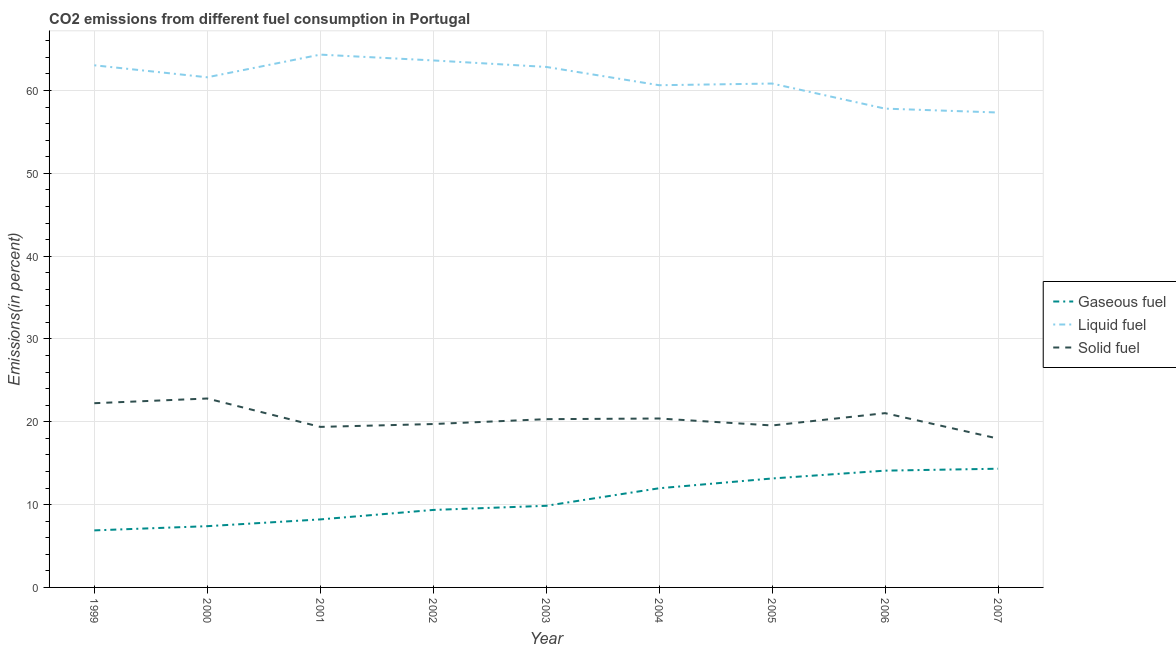What is the percentage of liquid fuel emission in 2003?
Keep it short and to the point. 62.85. Across all years, what is the maximum percentage of solid fuel emission?
Ensure brevity in your answer.  22.81. Across all years, what is the minimum percentage of liquid fuel emission?
Provide a succinct answer. 57.34. In which year was the percentage of gaseous fuel emission minimum?
Offer a terse response. 1999. What is the total percentage of liquid fuel emission in the graph?
Your answer should be compact. 552.1. What is the difference between the percentage of gaseous fuel emission in 2001 and that in 2003?
Provide a succinct answer. -1.64. What is the difference between the percentage of solid fuel emission in 2007 and the percentage of gaseous fuel emission in 2006?
Ensure brevity in your answer.  3.87. What is the average percentage of solid fuel emission per year?
Offer a very short reply. 20.38. In the year 2004, what is the difference between the percentage of gaseous fuel emission and percentage of liquid fuel emission?
Make the answer very short. -48.66. What is the ratio of the percentage of gaseous fuel emission in 2003 to that in 2006?
Provide a short and direct response. 0.7. What is the difference between the highest and the second highest percentage of gaseous fuel emission?
Offer a terse response. 0.23. What is the difference between the highest and the lowest percentage of gaseous fuel emission?
Your answer should be very brief. 7.45. Is it the case that in every year, the sum of the percentage of gaseous fuel emission and percentage of liquid fuel emission is greater than the percentage of solid fuel emission?
Keep it short and to the point. Yes. Are the values on the major ticks of Y-axis written in scientific E-notation?
Your answer should be compact. No. Does the graph contain any zero values?
Offer a very short reply. No. Where does the legend appear in the graph?
Provide a short and direct response. Center right. How are the legend labels stacked?
Your answer should be compact. Vertical. What is the title of the graph?
Your answer should be compact. CO2 emissions from different fuel consumption in Portugal. What is the label or title of the Y-axis?
Ensure brevity in your answer.  Emissions(in percent). What is the Emissions(in percent) in Gaseous fuel in 1999?
Provide a short and direct response. 6.89. What is the Emissions(in percent) of Liquid fuel in 1999?
Your answer should be compact. 63.05. What is the Emissions(in percent) of Solid fuel in 1999?
Your response must be concise. 22.24. What is the Emissions(in percent) in Gaseous fuel in 2000?
Ensure brevity in your answer.  7.4. What is the Emissions(in percent) in Liquid fuel in 2000?
Ensure brevity in your answer.  61.6. What is the Emissions(in percent) of Solid fuel in 2000?
Your answer should be very brief. 22.81. What is the Emissions(in percent) in Gaseous fuel in 2001?
Make the answer very short. 8.21. What is the Emissions(in percent) in Liquid fuel in 2001?
Provide a succinct answer. 64.34. What is the Emissions(in percent) of Solid fuel in 2001?
Your answer should be very brief. 19.38. What is the Emissions(in percent) of Gaseous fuel in 2002?
Keep it short and to the point. 9.36. What is the Emissions(in percent) of Liquid fuel in 2002?
Your response must be concise. 63.63. What is the Emissions(in percent) in Solid fuel in 2002?
Provide a short and direct response. 19.73. What is the Emissions(in percent) of Gaseous fuel in 2003?
Offer a very short reply. 9.86. What is the Emissions(in percent) in Liquid fuel in 2003?
Provide a succinct answer. 62.85. What is the Emissions(in percent) in Solid fuel in 2003?
Your response must be concise. 20.32. What is the Emissions(in percent) in Gaseous fuel in 2004?
Your answer should be compact. 11.97. What is the Emissions(in percent) of Liquid fuel in 2004?
Provide a succinct answer. 60.64. What is the Emissions(in percent) in Solid fuel in 2004?
Offer a very short reply. 20.4. What is the Emissions(in percent) in Gaseous fuel in 2005?
Your answer should be very brief. 13.16. What is the Emissions(in percent) in Liquid fuel in 2005?
Your answer should be compact. 60.84. What is the Emissions(in percent) of Solid fuel in 2005?
Offer a terse response. 19.56. What is the Emissions(in percent) of Gaseous fuel in 2006?
Provide a short and direct response. 14.1. What is the Emissions(in percent) in Liquid fuel in 2006?
Provide a succinct answer. 57.81. What is the Emissions(in percent) in Solid fuel in 2006?
Provide a short and direct response. 21.04. What is the Emissions(in percent) of Gaseous fuel in 2007?
Give a very brief answer. 14.33. What is the Emissions(in percent) of Liquid fuel in 2007?
Provide a short and direct response. 57.34. What is the Emissions(in percent) in Solid fuel in 2007?
Offer a terse response. 17.97. Across all years, what is the maximum Emissions(in percent) of Gaseous fuel?
Your answer should be very brief. 14.33. Across all years, what is the maximum Emissions(in percent) of Liquid fuel?
Keep it short and to the point. 64.34. Across all years, what is the maximum Emissions(in percent) of Solid fuel?
Ensure brevity in your answer.  22.81. Across all years, what is the minimum Emissions(in percent) of Gaseous fuel?
Make the answer very short. 6.89. Across all years, what is the minimum Emissions(in percent) in Liquid fuel?
Provide a short and direct response. 57.34. Across all years, what is the minimum Emissions(in percent) in Solid fuel?
Make the answer very short. 17.97. What is the total Emissions(in percent) of Gaseous fuel in the graph?
Ensure brevity in your answer.  95.27. What is the total Emissions(in percent) of Liquid fuel in the graph?
Your answer should be compact. 552.1. What is the total Emissions(in percent) in Solid fuel in the graph?
Your answer should be compact. 183.45. What is the difference between the Emissions(in percent) of Gaseous fuel in 1999 and that in 2000?
Offer a terse response. -0.51. What is the difference between the Emissions(in percent) in Liquid fuel in 1999 and that in 2000?
Your response must be concise. 1.45. What is the difference between the Emissions(in percent) of Solid fuel in 1999 and that in 2000?
Ensure brevity in your answer.  -0.57. What is the difference between the Emissions(in percent) of Gaseous fuel in 1999 and that in 2001?
Your answer should be very brief. -1.33. What is the difference between the Emissions(in percent) in Liquid fuel in 1999 and that in 2001?
Your response must be concise. -1.29. What is the difference between the Emissions(in percent) of Solid fuel in 1999 and that in 2001?
Give a very brief answer. 2.86. What is the difference between the Emissions(in percent) in Gaseous fuel in 1999 and that in 2002?
Offer a very short reply. -2.47. What is the difference between the Emissions(in percent) in Liquid fuel in 1999 and that in 2002?
Make the answer very short. -0.59. What is the difference between the Emissions(in percent) of Solid fuel in 1999 and that in 2002?
Give a very brief answer. 2.51. What is the difference between the Emissions(in percent) of Gaseous fuel in 1999 and that in 2003?
Provide a short and direct response. -2.97. What is the difference between the Emissions(in percent) in Liquid fuel in 1999 and that in 2003?
Your answer should be very brief. 0.2. What is the difference between the Emissions(in percent) in Solid fuel in 1999 and that in 2003?
Your answer should be very brief. 1.93. What is the difference between the Emissions(in percent) in Gaseous fuel in 1999 and that in 2004?
Offer a terse response. -5.09. What is the difference between the Emissions(in percent) of Liquid fuel in 1999 and that in 2004?
Offer a terse response. 2.41. What is the difference between the Emissions(in percent) in Solid fuel in 1999 and that in 2004?
Your response must be concise. 1.85. What is the difference between the Emissions(in percent) in Gaseous fuel in 1999 and that in 2005?
Provide a short and direct response. -6.27. What is the difference between the Emissions(in percent) of Liquid fuel in 1999 and that in 2005?
Provide a succinct answer. 2.2. What is the difference between the Emissions(in percent) of Solid fuel in 1999 and that in 2005?
Offer a terse response. 2.69. What is the difference between the Emissions(in percent) in Gaseous fuel in 1999 and that in 2006?
Make the answer very short. -7.21. What is the difference between the Emissions(in percent) in Liquid fuel in 1999 and that in 2006?
Ensure brevity in your answer.  5.23. What is the difference between the Emissions(in percent) in Solid fuel in 1999 and that in 2006?
Offer a terse response. 1.2. What is the difference between the Emissions(in percent) of Gaseous fuel in 1999 and that in 2007?
Offer a terse response. -7.45. What is the difference between the Emissions(in percent) in Liquid fuel in 1999 and that in 2007?
Your response must be concise. 5.7. What is the difference between the Emissions(in percent) in Solid fuel in 1999 and that in 2007?
Offer a terse response. 4.27. What is the difference between the Emissions(in percent) of Gaseous fuel in 2000 and that in 2001?
Make the answer very short. -0.82. What is the difference between the Emissions(in percent) of Liquid fuel in 2000 and that in 2001?
Offer a terse response. -2.74. What is the difference between the Emissions(in percent) in Solid fuel in 2000 and that in 2001?
Your answer should be very brief. 3.43. What is the difference between the Emissions(in percent) of Gaseous fuel in 2000 and that in 2002?
Keep it short and to the point. -1.96. What is the difference between the Emissions(in percent) of Liquid fuel in 2000 and that in 2002?
Give a very brief answer. -2.03. What is the difference between the Emissions(in percent) of Solid fuel in 2000 and that in 2002?
Your answer should be compact. 3.08. What is the difference between the Emissions(in percent) of Gaseous fuel in 2000 and that in 2003?
Keep it short and to the point. -2.46. What is the difference between the Emissions(in percent) of Liquid fuel in 2000 and that in 2003?
Your answer should be very brief. -1.25. What is the difference between the Emissions(in percent) in Solid fuel in 2000 and that in 2003?
Your answer should be very brief. 2.49. What is the difference between the Emissions(in percent) in Gaseous fuel in 2000 and that in 2004?
Provide a succinct answer. -4.58. What is the difference between the Emissions(in percent) in Liquid fuel in 2000 and that in 2004?
Give a very brief answer. 0.96. What is the difference between the Emissions(in percent) in Solid fuel in 2000 and that in 2004?
Offer a very short reply. 2.41. What is the difference between the Emissions(in percent) in Gaseous fuel in 2000 and that in 2005?
Make the answer very short. -5.76. What is the difference between the Emissions(in percent) of Liquid fuel in 2000 and that in 2005?
Keep it short and to the point. 0.76. What is the difference between the Emissions(in percent) of Solid fuel in 2000 and that in 2005?
Provide a short and direct response. 3.26. What is the difference between the Emissions(in percent) in Gaseous fuel in 2000 and that in 2006?
Offer a terse response. -6.71. What is the difference between the Emissions(in percent) of Liquid fuel in 2000 and that in 2006?
Your answer should be very brief. 3.78. What is the difference between the Emissions(in percent) of Solid fuel in 2000 and that in 2006?
Provide a short and direct response. 1.77. What is the difference between the Emissions(in percent) in Gaseous fuel in 2000 and that in 2007?
Provide a short and direct response. -6.94. What is the difference between the Emissions(in percent) in Liquid fuel in 2000 and that in 2007?
Ensure brevity in your answer.  4.25. What is the difference between the Emissions(in percent) in Solid fuel in 2000 and that in 2007?
Ensure brevity in your answer.  4.84. What is the difference between the Emissions(in percent) in Gaseous fuel in 2001 and that in 2002?
Make the answer very short. -1.14. What is the difference between the Emissions(in percent) of Liquid fuel in 2001 and that in 2002?
Your answer should be compact. 0.7. What is the difference between the Emissions(in percent) in Solid fuel in 2001 and that in 2002?
Make the answer very short. -0.34. What is the difference between the Emissions(in percent) of Gaseous fuel in 2001 and that in 2003?
Your answer should be compact. -1.64. What is the difference between the Emissions(in percent) in Liquid fuel in 2001 and that in 2003?
Provide a succinct answer. 1.49. What is the difference between the Emissions(in percent) in Solid fuel in 2001 and that in 2003?
Provide a succinct answer. -0.93. What is the difference between the Emissions(in percent) in Gaseous fuel in 2001 and that in 2004?
Offer a very short reply. -3.76. What is the difference between the Emissions(in percent) of Liquid fuel in 2001 and that in 2004?
Your answer should be compact. 3.7. What is the difference between the Emissions(in percent) in Solid fuel in 2001 and that in 2004?
Ensure brevity in your answer.  -1.01. What is the difference between the Emissions(in percent) of Gaseous fuel in 2001 and that in 2005?
Keep it short and to the point. -4.94. What is the difference between the Emissions(in percent) of Liquid fuel in 2001 and that in 2005?
Offer a very short reply. 3.49. What is the difference between the Emissions(in percent) of Solid fuel in 2001 and that in 2005?
Ensure brevity in your answer.  -0.17. What is the difference between the Emissions(in percent) in Gaseous fuel in 2001 and that in 2006?
Offer a terse response. -5.89. What is the difference between the Emissions(in percent) in Liquid fuel in 2001 and that in 2006?
Provide a succinct answer. 6.52. What is the difference between the Emissions(in percent) in Solid fuel in 2001 and that in 2006?
Make the answer very short. -1.66. What is the difference between the Emissions(in percent) in Gaseous fuel in 2001 and that in 2007?
Make the answer very short. -6.12. What is the difference between the Emissions(in percent) in Liquid fuel in 2001 and that in 2007?
Your response must be concise. 6.99. What is the difference between the Emissions(in percent) of Solid fuel in 2001 and that in 2007?
Your response must be concise. 1.41. What is the difference between the Emissions(in percent) of Gaseous fuel in 2002 and that in 2003?
Ensure brevity in your answer.  -0.5. What is the difference between the Emissions(in percent) in Liquid fuel in 2002 and that in 2003?
Your response must be concise. 0.78. What is the difference between the Emissions(in percent) of Solid fuel in 2002 and that in 2003?
Provide a short and direct response. -0.59. What is the difference between the Emissions(in percent) in Gaseous fuel in 2002 and that in 2004?
Ensure brevity in your answer.  -2.62. What is the difference between the Emissions(in percent) in Liquid fuel in 2002 and that in 2004?
Give a very brief answer. 2.99. What is the difference between the Emissions(in percent) in Solid fuel in 2002 and that in 2004?
Provide a short and direct response. -0.67. What is the difference between the Emissions(in percent) in Gaseous fuel in 2002 and that in 2005?
Your answer should be very brief. -3.8. What is the difference between the Emissions(in percent) in Liquid fuel in 2002 and that in 2005?
Your answer should be compact. 2.79. What is the difference between the Emissions(in percent) of Solid fuel in 2002 and that in 2005?
Provide a succinct answer. 0.17. What is the difference between the Emissions(in percent) in Gaseous fuel in 2002 and that in 2006?
Make the answer very short. -4.74. What is the difference between the Emissions(in percent) of Liquid fuel in 2002 and that in 2006?
Offer a very short reply. 5.82. What is the difference between the Emissions(in percent) of Solid fuel in 2002 and that in 2006?
Ensure brevity in your answer.  -1.31. What is the difference between the Emissions(in percent) in Gaseous fuel in 2002 and that in 2007?
Provide a short and direct response. -4.98. What is the difference between the Emissions(in percent) in Liquid fuel in 2002 and that in 2007?
Provide a succinct answer. 6.29. What is the difference between the Emissions(in percent) in Solid fuel in 2002 and that in 2007?
Your response must be concise. 1.76. What is the difference between the Emissions(in percent) in Gaseous fuel in 2003 and that in 2004?
Give a very brief answer. -2.12. What is the difference between the Emissions(in percent) of Liquid fuel in 2003 and that in 2004?
Your answer should be compact. 2.21. What is the difference between the Emissions(in percent) of Solid fuel in 2003 and that in 2004?
Keep it short and to the point. -0.08. What is the difference between the Emissions(in percent) in Gaseous fuel in 2003 and that in 2005?
Offer a very short reply. -3.3. What is the difference between the Emissions(in percent) of Liquid fuel in 2003 and that in 2005?
Your response must be concise. 2.01. What is the difference between the Emissions(in percent) of Solid fuel in 2003 and that in 2005?
Offer a very short reply. 0.76. What is the difference between the Emissions(in percent) in Gaseous fuel in 2003 and that in 2006?
Keep it short and to the point. -4.25. What is the difference between the Emissions(in percent) in Liquid fuel in 2003 and that in 2006?
Make the answer very short. 5.03. What is the difference between the Emissions(in percent) of Solid fuel in 2003 and that in 2006?
Offer a terse response. -0.73. What is the difference between the Emissions(in percent) of Gaseous fuel in 2003 and that in 2007?
Make the answer very short. -4.48. What is the difference between the Emissions(in percent) of Liquid fuel in 2003 and that in 2007?
Offer a very short reply. 5.5. What is the difference between the Emissions(in percent) in Solid fuel in 2003 and that in 2007?
Provide a short and direct response. 2.35. What is the difference between the Emissions(in percent) in Gaseous fuel in 2004 and that in 2005?
Provide a short and direct response. -1.18. What is the difference between the Emissions(in percent) in Liquid fuel in 2004 and that in 2005?
Make the answer very short. -0.2. What is the difference between the Emissions(in percent) of Solid fuel in 2004 and that in 2005?
Provide a succinct answer. 0.84. What is the difference between the Emissions(in percent) of Gaseous fuel in 2004 and that in 2006?
Ensure brevity in your answer.  -2.13. What is the difference between the Emissions(in percent) of Liquid fuel in 2004 and that in 2006?
Provide a short and direct response. 2.83. What is the difference between the Emissions(in percent) of Solid fuel in 2004 and that in 2006?
Your answer should be compact. -0.65. What is the difference between the Emissions(in percent) of Gaseous fuel in 2004 and that in 2007?
Ensure brevity in your answer.  -2.36. What is the difference between the Emissions(in percent) in Liquid fuel in 2004 and that in 2007?
Keep it short and to the point. 3.3. What is the difference between the Emissions(in percent) of Solid fuel in 2004 and that in 2007?
Provide a short and direct response. 2.42. What is the difference between the Emissions(in percent) in Gaseous fuel in 2005 and that in 2006?
Provide a succinct answer. -0.95. What is the difference between the Emissions(in percent) of Liquid fuel in 2005 and that in 2006?
Your response must be concise. 3.03. What is the difference between the Emissions(in percent) in Solid fuel in 2005 and that in 2006?
Offer a terse response. -1.49. What is the difference between the Emissions(in percent) of Gaseous fuel in 2005 and that in 2007?
Provide a succinct answer. -1.18. What is the difference between the Emissions(in percent) of Liquid fuel in 2005 and that in 2007?
Offer a terse response. 3.5. What is the difference between the Emissions(in percent) of Solid fuel in 2005 and that in 2007?
Your response must be concise. 1.58. What is the difference between the Emissions(in percent) in Gaseous fuel in 2006 and that in 2007?
Make the answer very short. -0.23. What is the difference between the Emissions(in percent) of Liquid fuel in 2006 and that in 2007?
Give a very brief answer. 0.47. What is the difference between the Emissions(in percent) of Solid fuel in 2006 and that in 2007?
Your answer should be compact. 3.07. What is the difference between the Emissions(in percent) of Gaseous fuel in 1999 and the Emissions(in percent) of Liquid fuel in 2000?
Keep it short and to the point. -54.71. What is the difference between the Emissions(in percent) in Gaseous fuel in 1999 and the Emissions(in percent) in Solid fuel in 2000?
Ensure brevity in your answer.  -15.92. What is the difference between the Emissions(in percent) of Liquid fuel in 1999 and the Emissions(in percent) of Solid fuel in 2000?
Your answer should be very brief. 40.23. What is the difference between the Emissions(in percent) in Gaseous fuel in 1999 and the Emissions(in percent) in Liquid fuel in 2001?
Give a very brief answer. -57.45. What is the difference between the Emissions(in percent) of Gaseous fuel in 1999 and the Emissions(in percent) of Solid fuel in 2001?
Keep it short and to the point. -12.5. What is the difference between the Emissions(in percent) in Liquid fuel in 1999 and the Emissions(in percent) in Solid fuel in 2001?
Offer a very short reply. 43.66. What is the difference between the Emissions(in percent) in Gaseous fuel in 1999 and the Emissions(in percent) in Liquid fuel in 2002?
Provide a succinct answer. -56.74. What is the difference between the Emissions(in percent) of Gaseous fuel in 1999 and the Emissions(in percent) of Solid fuel in 2002?
Your answer should be compact. -12.84. What is the difference between the Emissions(in percent) of Liquid fuel in 1999 and the Emissions(in percent) of Solid fuel in 2002?
Provide a short and direct response. 43.32. What is the difference between the Emissions(in percent) in Gaseous fuel in 1999 and the Emissions(in percent) in Liquid fuel in 2003?
Keep it short and to the point. -55.96. What is the difference between the Emissions(in percent) in Gaseous fuel in 1999 and the Emissions(in percent) in Solid fuel in 2003?
Provide a short and direct response. -13.43. What is the difference between the Emissions(in percent) of Liquid fuel in 1999 and the Emissions(in percent) of Solid fuel in 2003?
Offer a very short reply. 42.73. What is the difference between the Emissions(in percent) in Gaseous fuel in 1999 and the Emissions(in percent) in Liquid fuel in 2004?
Give a very brief answer. -53.75. What is the difference between the Emissions(in percent) of Gaseous fuel in 1999 and the Emissions(in percent) of Solid fuel in 2004?
Keep it short and to the point. -13.51. What is the difference between the Emissions(in percent) in Liquid fuel in 1999 and the Emissions(in percent) in Solid fuel in 2004?
Keep it short and to the point. 42.65. What is the difference between the Emissions(in percent) in Gaseous fuel in 1999 and the Emissions(in percent) in Liquid fuel in 2005?
Provide a succinct answer. -53.95. What is the difference between the Emissions(in percent) of Gaseous fuel in 1999 and the Emissions(in percent) of Solid fuel in 2005?
Ensure brevity in your answer.  -12.67. What is the difference between the Emissions(in percent) of Liquid fuel in 1999 and the Emissions(in percent) of Solid fuel in 2005?
Your response must be concise. 43.49. What is the difference between the Emissions(in percent) in Gaseous fuel in 1999 and the Emissions(in percent) in Liquid fuel in 2006?
Provide a short and direct response. -50.93. What is the difference between the Emissions(in percent) in Gaseous fuel in 1999 and the Emissions(in percent) in Solid fuel in 2006?
Offer a very short reply. -14.16. What is the difference between the Emissions(in percent) of Liquid fuel in 1999 and the Emissions(in percent) of Solid fuel in 2006?
Provide a succinct answer. 42. What is the difference between the Emissions(in percent) in Gaseous fuel in 1999 and the Emissions(in percent) in Liquid fuel in 2007?
Provide a short and direct response. -50.46. What is the difference between the Emissions(in percent) in Gaseous fuel in 1999 and the Emissions(in percent) in Solid fuel in 2007?
Your answer should be compact. -11.08. What is the difference between the Emissions(in percent) in Liquid fuel in 1999 and the Emissions(in percent) in Solid fuel in 2007?
Ensure brevity in your answer.  45.07. What is the difference between the Emissions(in percent) of Gaseous fuel in 2000 and the Emissions(in percent) of Liquid fuel in 2001?
Provide a succinct answer. -56.94. What is the difference between the Emissions(in percent) of Gaseous fuel in 2000 and the Emissions(in percent) of Solid fuel in 2001?
Ensure brevity in your answer.  -11.99. What is the difference between the Emissions(in percent) of Liquid fuel in 2000 and the Emissions(in percent) of Solid fuel in 2001?
Ensure brevity in your answer.  42.21. What is the difference between the Emissions(in percent) in Gaseous fuel in 2000 and the Emissions(in percent) in Liquid fuel in 2002?
Your answer should be very brief. -56.24. What is the difference between the Emissions(in percent) of Gaseous fuel in 2000 and the Emissions(in percent) of Solid fuel in 2002?
Offer a terse response. -12.33. What is the difference between the Emissions(in percent) in Liquid fuel in 2000 and the Emissions(in percent) in Solid fuel in 2002?
Keep it short and to the point. 41.87. What is the difference between the Emissions(in percent) in Gaseous fuel in 2000 and the Emissions(in percent) in Liquid fuel in 2003?
Keep it short and to the point. -55.45. What is the difference between the Emissions(in percent) of Gaseous fuel in 2000 and the Emissions(in percent) of Solid fuel in 2003?
Your answer should be compact. -12.92. What is the difference between the Emissions(in percent) of Liquid fuel in 2000 and the Emissions(in percent) of Solid fuel in 2003?
Keep it short and to the point. 41.28. What is the difference between the Emissions(in percent) of Gaseous fuel in 2000 and the Emissions(in percent) of Liquid fuel in 2004?
Keep it short and to the point. -53.24. What is the difference between the Emissions(in percent) in Gaseous fuel in 2000 and the Emissions(in percent) in Solid fuel in 2004?
Keep it short and to the point. -13. What is the difference between the Emissions(in percent) of Liquid fuel in 2000 and the Emissions(in percent) of Solid fuel in 2004?
Your response must be concise. 41.2. What is the difference between the Emissions(in percent) of Gaseous fuel in 2000 and the Emissions(in percent) of Liquid fuel in 2005?
Offer a terse response. -53.45. What is the difference between the Emissions(in percent) of Gaseous fuel in 2000 and the Emissions(in percent) of Solid fuel in 2005?
Give a very brief answer. -12.16. What is the difference between the Emissions(in percent) in Liquid fuel in 2000 and the Emissions(in percent) in Solid fuel in 2005?
Your response must be concise. 42.04. What is the difference between the Emissions(in percent) in Gaseous fuel in 2000 and the Emissions(in percent) in Liquid fuel in 2006?
Ensure brevity in your answer.  -50.42. What is the difference between the Emissions(in percent) in Gaseous fuel in 2000 and the Emissions(in percent) in Solid fuel in 2006?
Offer a very short reply. -13.65. What is the difference between the Emissions(in percent) in Liquid fuel in 2000 and the Emissions(in percent) in Solid fuel in 2006?
Offer a very short reply. 40.55. What is the difference between the Emissions(in percent) in Gaseous fuel in 2000 and the Emissions(in percent) in Liquid fuel in 2007?
Provide a succinct answer. -49.95. What is the difference between the Emissions(in percent) of Gaseous fuel in 2000 and the Emissions(in percent) of Solid fuel in 2007?
Make the answer very short. -10.58. What is the difference between the Emissions(in percent) of Liquid fuel in 2000 and the Emissions(in percent) of Solid fuel in 2007?
Make the answer very short. 43.63. What is the difference between the Emissions(in percent) of Gaseous fuel in 2001 and the Emissions(in percent) of Liquid fuel in 2002?
Your answer should be compact. -55.42. What is the difference between the Emissions(in percent) of Gaseous fuel in 2001 and the Emissions(in percent) of Solid fuel in 2002?
Offer a very short reply. -11.52. What is the difference between the Emissions(in percent) of Liquid fuel in 2001 and the Emissions(in percent) of Solid fuel in 2002?
Your answer should be compact. 44.61. What is the difference between the Emissions(in percent) in Gaseous fuel in 2001 and the Emissions(in percent) in Liquid fuel in 2003?
Your answer should be compact. -54.64. What is the difference between the Emissions(in percent) in Gaseous fuel in 2001 and the Emissions(in percent) in Solid fuel in 2003?
Make the answer very short. -12.1. What is the difference between the Emissions(in percent) in Liquid fuel in 2001 and the Emissions(in percent) in Solid fuel in 2003?
Your response must be concise. 44.02. What is the difference between the Emissions(in percent) of Gaseous fuel in 2001 and the Emissions(in percent) of Liquid fuel in 2004?
Your answer should be compact. -52.43. What is the difference between the Emissions(in percent) in Gaseous fuel in 2001 and the Emissions(in percent) in Solid fuel in 2004?
Your answer should be compact. -12.18. What is the difference between the Emissions(in percent) in Liquid fuel in 2001 and the Emissions(in percent) in Solid fuel in 2004?
Your answer should be very brief. 43.94. What is the difference between the Emissions(in percent) of Gaseous fuel in 2001 and the Emissions(in percent) of Liquid fuel in 2005?
Offer a very short reply. -52.63. What is the difference between the Emissions(in percent) in Gaseous fuel in 2001 and the Emissions(in percent) in Solid fuel in 2005?
Make the answer very short. -11.34. What is the difference between the Emissions(in percent) of Liquid fuel in 2001 and the Emissions(in percent) of Solid fuel in 2005?
Your answer should be very brief. 44.78. What is the difference between the Emissions(in percent) of Gaseous fuel in 2001 and the Emissions(in percent) of Liquid fuel in 2006?
Provide a short and direct response. -49.6. What is the difference between the Emissions(in percent) of Gaseous fuel in 2001 and the Emissions(in percent) of Solid fuel in 2006?
Make the answer very short. -12.83. What is the difference between the Emissions(in percent) of Liquid fuel in 2001 and the Emissions(in percent) of Solid fuel in 2006?
Offer a very short reply. 43.29. What is the difference between the Emissions(in percent) of Gaseous fuel in 2001 and the Emissions(in percent) of Liquid fuel in 2007?
Your answer should be compact. -49.13. What is the difference between the Emissions(in percent) in Gaseous fuel in 2001 and the Emissions(in percent) in Solid fuel in 2007?
Your answer should be very brief. -9.76. What is the difference between the Emissions(in percent) of Liquid fuel in 2001 and the Emissions(in percent) of Solid fuel in 2007?
Ensure brevity in your answer.  46.36. What is the difference between the Emissions(in percent) of Gaseous fuel in 2002 and the Emissions(in percent) of Liquid fuel in 2003?
Your answer should be very brief. -53.49. What is the difference between the Emissions(in percent) of Gaseous fuel in 2002 and the Emissions(in percent) of Solid fuel in 2003?
Your response must be concise. -10.96. What is the difference between the Emissions(in percent) in Liquid fuel in 2002 and the Emissions(in percent) in Solid fuel in 2003?
Your answer should be very brief. 43.31. What is the difference between the Emissions(in percent) in Gaseous fuel in 2002 and the Emissions(in percent) in Liquid fuel in 2004?
Provide a succinct answer. -51.28. What is the difference between the Emissions(in percent) in Gaseous fuel in 2002 and the Emissions(in percent) in Solid fuel in 2004?
Provide a short and direct response. -11.04. What is the difference between the Emissions(in percent) of Liquid fuel in 2002 and the Emissions(in percent) of Solid fuel in 2004?
Ensure brevity in your answer.  43.23. What is the difference between the Emissions(in percent) of Gaseous fuel in 2002 and the Emissions(in percent) of Liquid fuel in 2005?
Provide a short and direct response. -51.49. What is the difference between the Emissions(in percent) of Gaseous fuel in 2002 and the Emissions(in percent) of Solid fuel in 2005?
Your answer should be compact. -10.2. What is the difference between the Emissions(in percent) in Liquid fuel in 2002 and the Emissions(in percent) in Solid fuel in 2005?
Ensure brevity in your answer.  44.08. What is the difference between the Emissions(in percent) of Gaseous fuel in 2002 and the Emissions(in percent) of Liquid fuel in 2006?
Give a very brief answer. -48.46. What is the difference between the Emissions(in percent) in Gaseous fuel in 2002 and the Emissions(in percent) in Solid fuel in 2006?
Your response must be concise. -11.69. What is the difference between the Emissions(in percent) of Liquid fuel in 2002 and the Emissions(in percent) of Solid fuel in 2006?
Ensure brevity in your answer.  42.59. What is the difference between the Emissions(in percent) in Gaseous fuel in 2002 and the Emissions(in percent) in Liquid fuel in 2007?
Offer a terse response. -47.99. What is the difference between the Emissions(in percent) of Gaseous fuel in 2002 and the Emissions(in percent) of Solid fuel in 2007?
Keep it short and to the point. -8.62. What is the difference between the Emissions(in percent) in Liquid fuel in 2002 and the Emissions(in percent) in Solid fuel in 2007?
Provide a short and direct response. 45.66. What is the difference between the Emissions(in percent) in Gaseous fuel in 2003 and the Emissions(in percent) in Liquid fuel in 2004?
Provide a succinct answer. -50.78. What is the difference between the Emissions(in percent) in Gaseous fuel in 2003 and the Emissions(in percent) in Solid fuel in 2004?
Provide a short and direct response. -10.54. What is the difference between the Emissions(in percent) in Liquid fuel in 2003 and the Emissions(in percent) in Solid fuel in 2004?
Offer a very short reply. 42.45. What is the difference between the Emissions(in percent) in Gaseous fuel in 2003 and the Emissions(in percent) in Liquid fuel in 2005?
Offer a very short reply. -50.99. What is the difference between the Emissions(in percent) of Gaseous fuel in 2003 and the Emissions(in percent) of Solid fuel in 2005?
Keep it short and to the point. -9.7. What is the difference between the Emissions(in percent) in Liquid fuel in 2003 and the Emissions(in percent) in Solid fuel in 2005?
Ensure brevity in your answer.  43.29. What is the difference between the Emissions(in percent) in Gaseous fuel in 2003 and the Emissions(in percent) in Liquid fuel in 2006?
Keep it short and to the point. -47.96. What is the difference between the Emissions(in percent) of Gaseous fuel in 2003 and the Emissions(in percent) of Solid fuel in 2006?
Your answer should be compact. -11.19. What is the difference between the Emissions(in percent) of Liquid fuel in 2003 and the Emissions(in percent) of Solid fuel in 2006?
Your answer should be compact. 41.81. What is the difference between the Emissions(in percent) of Gaseous fuel in 2003 and the Emissions(in percent) of Liquid fuel in 2007?
Make the answer very short. -47.49. What is the difference between the Emissions(in percent) of Gaseous fuel in 2003 and the Emissions(in percent) of Solid fuel in 2007?
Your response must be concise. -8.12. What is the difference between the Emissions(in percent) of Liquid fuel in 2003 and the Emissions(in percent) of Solid fuel in 2007?
Your answer should be very brief. 44.88. What is the difference between the Emissions(in percent) in Gaseous fuel in 2004 and the Emissions(in percent) in Liquid fuel in 2005?
Your answer should be very brief. -48.87. What is the difference between the Emissions(in percent) in Gaseous fuel in 2004 and the Emissions(in percent) in Solid fuel in 2005?
Keep it short and to the point. -7.58. What is the difference between the Emissions(in percent) in Liquid fuel in 2004 and the Emissions(in percent) in Solid fuel in 2005?
Offer a very short reply. 41.08. What is the difference between the Emissions(in percent) of Gaseous fuel in 2004 and the Emissions(in percent) of Liquid fuel in 2006?
Keep it short and to the point. -45.84. What is the difference between the Emissions(in percent) in Gaseous fuel in 2004 and the Emissions(in percent) in Solid fuel in 2006?
Offer a very short reply. -9.07. What is the difference between the Emissions(in percent) of Liquid fuel in 2004 and the Emissions(in percent) of Solid fuel in 2006?
Keep it short and to the point. 39.6. What is the difference between the Emissions(in percent) in Gaseous fuel in 2004 and the Emissions(in percent) in Liquid fuel in 2007?
Offer a very short reply. -45.37. What is the difference between the Emissions(in percent) in Gaseous fuel in 2004 and the Emissions(in percent) in Solid fuel in 2007?
Offer a terse response. -6. What is the difference between the Emissions(in percent) of Liquid fuel in 2004 and the Emissions(in percent) of Solid fuel in 2007?
Your answer should be very brief. 42.67. What is the difference between the Emissions(in percent) in Gaseous fuel in 2005 and the Emissions(in percent) in Liquid fuel in 2006?
Your response must be concise. -44.66. What is the difference between the Emissions(in percent) of Gaseous fuel in 2005 and the Emissions(in percent) of Solid fuel in 2006?
Make the answer very short. -7.89. What is the difference between the Emissions(in percent) in Liquid fuel in 2005 and the Emissions(in percent) in Solid fuel in 2006?
Your response must be concise. 39.8. What is the difference between the Emissions(in percent) of Gaseous fuel in 2005 and the Emissions(in percent) of Liquid fuel in 2007?
Ensure brevity in your answer.  -44.19. What is the difference between the Emissions(in percent) in Gaseous fuel in 2005 and the Emissions(in percent) in Solid fuel in 2007?
Ensure brevity in your answer.  -4.82. What is the difference between the Emissions(in percent) in Liquid fuel in 2005 and the Emissions(in percent) in Solid fuel in 2007?
Provide a short and direct response. 42.87. What is the difference between the Emissions(in percent) in Gaseous fuel in 2006 and the Emissions(in percent) in Liquid fuel in 2007?
Offer a terse response. -43.24. What is the difference between the Emissions(in percent) of Gaseous fuel in 2006 and the Emissions(in percent) of Solid fuel in 2007?
Your answer should be very brief. -3.87. What is the difference between the Emissions(in percent) in Liquid fuel in 2006 and the Emissions(in percent) in Solid fuel in 2007?
Offer a very short reply. 39.84. What is the average Emissions(in percent) in Gaseous fuel per year?
Make the answer very short. 10.59. What is the average Emissions(in percent) in Liquid fuel per year?
Make the answer very short. 61.34. What is the average Emissions(in percent) in Solid fuel per year?
Your answer should be very brief. 20.38. In the year 1999, what is the difference between the Emissions(in percent) in Gaseous fuel and Emissions(in percent) in Liquid fuel?
Keep it short and to the point. -56.16. In the year 1999, what is the difference between the Emissions(in percent) of Gaseous fuel and Emissions(in percent) of Solid fuel?
Offer a terse response. -15.36. In the year 1999, what is the difference between the Emissions(in percent) of Liquid fuel and Emissions(in percent) of Solid fuel?
Your answer should be compact. 40.8. In the year 2000, what is the difference between the Emissions(in percent) of Gaseous fuel and Emissions(in percent) of Liquid fuel?
Provide a succinct answer. -54.2. In the year 2000, what is the difference between the Emissions(in percent) in Gaseous fuel and Emissions(in percent) in Solid fuel?
Offer a terse response. -15.42. In the year 2000, what is the difference between the Emissions(in percent) of Liquid fuel and Emissions(in percent) of Solid fuel?
Ensure brevity in your answer.  38.79. In the year 2001, what is the difference between the Emissions(in percent) of Gaseous fuel and Emissions(in percent) of Liquid fuel?
Ensure brevity in your answer.  -56.12. In the year 2001, what is the difference between the Emissions(in percent) of Gaseous fuel and Emissions(in percent) of Solid fuel?
Offer a terse response. -11.17. In the year 2001, what is the difference between the Emissions(in percent) in Liquid fuel and Emissions(in percent) in Solid fuel?
Offer a terse response. 44.95. In the year 2002, what is the difference between the Emissions(in percent) of Gaseous fuel and Emissions(in percent) of Liquid fuel?
Provide a short and direct response. -54.28. In the year 2002, what is the difference between the Emissions(in percent) in Gaseous fuel and Emissions(in percent) in Solid fuel?
Keep it short and to the point. -10.37. In the year 2002, what is the difference between the Emissions(in percent) in Liquid fuel and Emissions(in percent) in Solid fuel?
Keep it short and to the point. 43.9. In the year 2003, what is the difference between the Emissions(in percent) of Gaseous fuel and Emissions(in percent) of Liquid fuel?
Ensure brevity in your answer.  -52.99. In the year 2003, what is the difference between the Emissions(in percent) in Gaseous fuel and Emissions(in percent) in Solid fuel?
Provide a short and direct response. -10.46. In the year 2003, what is the difference between the Emissions(in percent) in Liquid fuel and Emissions(in percent) in Solid fuel?
Provide a short and direct response. 42.53. In the year 2004, what is the difference between the Emissions(in percent) in Gaseous fuel and Emissions(in percent) in Liquid fuel?
Keep it short and to the point. -48.66. In the year 2004, what is the difference between the Emissions(in percent) of Gaseous fuel and Emissions(in percent) of Solid fuel?
Your response must be concise. -8.42. In the year 2004, what is the difference between the Emissions(in percent) in Liquid fuel and Emissions(in percent) in Solid fuel?
Provide a short and direct response. 40.24. In the year 2005, what is the difference between the Emissions(in percent) in Gaseous fuel and Emissions(in percent) in Liquid fuel?
Offer a very short reply. -47.69. In the year 2005, what is the difference between the Emissions(in percent) of Gaseous fuel and Emissions(in percent) of Solid fuel?
Provide a succinct answer. -6.4. In the year 2005, what is the difference between the Emissions(in percent) of Liquid fuel and Emissions(in percent) of Solid fuel?
Your response must be concise. 41.29. In the year 2006, what is the difference between the Emissions(in percent) in Gaseous fuel and Emissions(in percent) in Liquid fuel?
Provide a succinct answer. -43.71. In the year 2006, what is the difference between the Emissions(in percent) of Gaseous fuel and Emissions(in percent) of Solid fuel?
Provide a short and direct response. -6.94. In the year 2006, what is the difference between the Emissions(in percent) in Liquid fuel and Emissions(in percent) in Solid fuel?
Keep it short and to the point. 36.77. In the year 2007, what is the difference between the Emissions(in percent) in Gaseous fuel and Emissions(in percent) in Liquid fuel?
Your answer should be very brief. -43.01. In the year 2007, what is the difference between the Emissions(in percent) in Gaseous fuel and Emissions(in percent) in Solid fuel?
Your answer should be very brief. -3.64. In the year 2007, what is the difference between the Emissions(in percent) in Liquid fuel and Emissions(in percent) in Solid fuel?
Your response must be concise. 39.37. What is the ratio of the Emissions(in percent) in Gaseous fuel in 1999 to that in 2000?
Keep it short and to the point. 0.93. What is the ratio of the Emissions(in percent) of Liquid fuel in 1999 to that in 2000?
Your response must be concise. 1.02. What is the ratio of the Emissions(in percent) of Solid fuel in 1999 to that in 2000?
Offer a very short reply. 0.98. What is the ratio of the Emissions(in percent) in Gaseous fuel in 1999 to that in 2001?
Offer a very short reply. 0.84. What is the ratio of the Emissions(in percent) in Solid fuel in 1999 to that in 2001?
Your response must be concise. 1.15. What is the ratio of the Emissions(in percent) of Gaseous fuel in 1999 to that in 2002?
Offer a very short reply. 0.74. What is the ratio of the Emissions(in percent) of Solid fuel in 1999 to that in 2002?
Ensure brevity in your answer.  1.13. What is the ratio of the Emissions(in percent) in Gaseous fuel in 1999 to that in 2003?
Offer a very short reply. 0.7. What is the ratio of the Emissions(in percent) of Solid fuel in 1999 to that in 2003?
Offer a very short reply. 1.09. What is the ratio of the Emissions(in percent) in Gaseous fuel in 1999 to that in 2004?
Keep it short and to the point. 0.58. What is the ratio of the Emissions(in percent) in Liquid fuel in 1999 to that in 2004?
Provide a succinct answer. 1.04. What is the ratio of the Emissions(in percent) of Solid fuel in 1999 to that in 2004?
Your answer should be very brief. 1.09. What is the ratio of the Emissions(in percent) of Gaseous fuel in 1999 to that in 2005?
Provide a short and direct response. 0.52. What is the ratio of the Emissions(in percent) of Liquid fuel in 1999 to that in 2005?
Offer a terse response. 1.04. What is the ratio of the Emissions(in percent) in Solid fuel in 1999 to that in 2005?
Provide a succinct answer. 1.14. What is the ratio of the Emissions(in percent) of Gaseous fuel in 1999 to that in 2006?
Your response must be concise. 0.49. What is the ratio of the Emissions(in percent) in Liquid fuel in 1999 to that in 2006?
Offer a terse response. 1.09. What is the ratio of the Emissions(in percent) of Solid fuel in 1999 to that in 2006?
Ensure brevity in your answer.  1.06. What is the ratio of the Emissions(in percent) of Gaseous fuel in 1999 to that in 2007?
Provide a short and direct response. 0.48. What is the ratio of the Emissions(in percent) in Liquid fuel in 1999 to that in 2007?
Your answer should be very brief. 1.1. What is the ratio of the Emissions(in percent) in Solid fuel in 1999 to that in 2007?
Offer a very short reply. 1.24. What is the ratio of the Emissions(in percent) in Gaseous fuel in 2000 to that in 2001?
Give a very brief answer. 0.9. What is the ratio of the Emissions(in percent) of Liquid fuel in 2000 to that in 2001?
Give a very brief answer. 0.96. What is the ratio of the Emissions(in percent) in Solid fuel in 2000 to that in 2001?
Give a very brief answer. 1.18. What is the ratio of the Emissions(in percent) in Gaseous fuel in 2000 to that in 2002?
Your answer should be very brief. 0.79. What is the ratio of the Emissions(in percent) of Liquid fuel in 2000 to that in 2002?
Offer a very short reply. 0.97. What is the ratio of the Emissions(in percent) of Solid fuel in 2000 to that in 2002?
Provide a short and direct response. 1.16. What is the ratio of the Emissions(in percent) of Gaseous fuel in 2000 to that in 2003?
Make the answer very short. 0.75. What is the ratio of the Emissions(in percent) of Liquid fuel in 2000 to that in 2003?
Ensure brevity in your answer.  0.98. What is the ratio of the Emissions(in percent) in Solid fuel in 2000 to that in 2003?
Provide a short and direct response. 1.12. What is the ratio of the Emissions(in percent) in Gaseous fuel in 2000 to that in 2004?
Ensure brevity in your answer.  0.62. What is the ratio of the Emissions(in percent) of Liquid fuel in 2000 to that in 2004?
Your answer should be compact. 1.02. What is the ratio of the Emissions(in percent) of Solid fuel in 2000 to that in 2004?
Your response must be concise. 1.12. What is the ratio of the Emissions(in percent) in Gaseous fuel in 2000 to that in 2005?
Provide a short and direct response. 0.56. What is the ratio of the Emissions(in percent) of Liquid fuel in 2000 to that in 2005?
Your response must be concise. 1.01. What is the ratio of the Emissions(in percent) of Solid fuel in 2000 to that in 2005?
Provide a short and direct response. 1.17. What is the ratio of the Emissions(in percent) in Gaseous fuel in 2000 to that in 2006?
Provide a short and direct response. 0.52. What is the ratio of the Emissions(in percent) in Liquid fuel in 2000 to that in 2006?
Your answer should be compact. 1.07. What is the ratio of the Emissions(in percent) in Solid fuel in 2000 to that in 2006?
Offer a very short reply. 1.08. What is the ratio of the Emissions(in percent) of Gaseous fuel in 2000 to that in 2007?
Give a very brief answer. 0.52. What is the ratio of the Emissions(in percent) of Liquid fuel in 2000 to that in 2007?
Ensure brevity in your answer.  1.07. What is the ratio of the Emissions(in percent) of Solid fuel in 2000 to that in 2007?
Your answer should be compact. 1.27. What is the ratio of the Emissions(in percent) in Gaseous fuel in 2001 to that in 2002?
Your answer should be very brief. 0.88. What is the ratio of the Emissions(in percent) of Liquid fuel in 2001 to that in 2002?
Provide a short and direct response. 1.01. What is the ratio of the Emissions(in percent) in Solid fuel in 2001 to that in 2002?
Ensure brevity in your answer.  0.98. What is the ratio of the Emissions(in percent) of Liquid fuel in 2001 to that in 2003?
Ensure brevity in your answer.  1.02. What is the ratio of the Emissions(in percent) of Solid fuel in 2001 to that in 2003?
Provide a succinct answer. 0.95. What is the ratio of the Emissions(in percent) in Gaseous fuel in 2001 to that in 2004?
Provide a short and direct response. 0.69. What is the ratio of the Emissions(in percent) of Liquid fuel in 2001 to that in 2004?
Offer a very short reply. 1.06. What is the ratio of the Emissions(in percent) in Solid fuel in 2001 to that in 2004?
Your response must be concise. 0.95. What is the ratio of the Emissions(in percent) in Gaseous fuel in 2001 to that in 2005?
Ensure brevity in your answer.  0.62. What is the ratio of the Emissions(in percent) of Liquid fuel in 2001 to that in 2005?
Keep it short and to the point. 1.06. What is the ratio of the Emissions(in percent) in Gaseous fuel in 2001 to that in 2006?
Your response must be concise. 0.58. What is the ratio of the Emissions(in percent) in Liquid fuel in 2001 to that in 2006?
Offer a terse response. 1.11. What is the ratio of the Emissions(in percent) in Solid fuel in 2001 to that in 2006?
Give a very brief answer. 0.92. What is the ratio of the Emissions(in percent) of Gaseous fuel in 2001 to that in 2007?
Provide a succinct answer. 0.57. What is the ratio of the Emissions(in percent) of Liquid fuel in 2001 to that in 2007?
Ensure brevity in your answer.  1.12. What is the ratio of the Emissions(in percent) in Solid fuel in 2001 to that in 2007?
Your answer should be compact. 1.08. What is the ratio of the Emissions(in percent) in Gaseous fuel in 2002 to that in 2003?
Your answer should be very brief. 0.95. What is the ratio of the Emissions(in percent) of Liquid fuel in 2002 to that in 2003?
Provide a short and direct response. 1.01. What is the ratio of the Emissions(in percent) of Gaseous fuel in 2002 to that in 2004?
Keep it short and to the point. 0.78. What is the ratio of the Emissions(in percent) of Liquid fuel in 2002 to that in 2004?
Your answer should be compact. 1.05. What is the ratio of the Emissions(in percent) in Solid fuel in 2002 to that in 2004?
Offer a very short reply. 0.97. What is the ratio of the Emissions(in percent) of Gaseous fuel in 2002 to that in 2005?
Provide a short and direct response. 0.71. What is the ratio of the Emissions(in percent) of Liquid fuel in 2002 to that in 2005?
Make the answer very short. 1.05. What is the ratio of the Emissions(in percent) of Solid fuel in 2002 to that in 2005?
Offer a terse response. 1.01. What is the ratio of the Emissions(in percent) in Gaseous fuel in 2002 to that in 2006?
Give a very brief answer. 0.66. What is the ratio of the Emissions(in percent) of Liquid fuel in 2002 to that in 2006?
Provide a succinct answer. 1.1. What is the ratio of the Emissions(in percent) of Solid fuel in 2002 to that in 2006?
Keep it short and to the point. 0.94. What is the ratio of the Emissions(in percent) in Gaseous fuel in 2002 to that in 2007?
Your answer should be compact. 0.65. What is the ratio of the Emissions(in percent) in Liquid fuel in 2002 to that in 2007?
Your response must be concise. 1.11. What is the ratio of the Emissions(in percent) in Solid fuel in 2002 to that in 2007?
Offer a very short reply. 1.1. What is the ratio of the Emissions(in percent) of Gaseous fuel in 2003 to that in 2004?
Offer a terse response. 0.82. What is the ratio of the Emissions(in percent) in Liquid fuel in 2003 to that in 2004?
Make the answer very short. 1.04. What is the ratio of the Emissions(in percent) in Solid fuel in 2003 to that in 2004?
Ensure brevity in your answer.  1. What is the ratio of the Emissions(in percent) in Gaseous fuel in 2003 to that in 2005?
Keep it short and to the point. 0.75. What is the ratio of the Emissions(in percent) of Liquid fuel in 2003 to that in 2005?
Offer a very short reply. 1.03. What is the ratio of the Emissions(in percent) in Solid fuel in 2003 to that in 2005?
Offer a very short reply. 1.04. What is the ratio of the Emissions(in percent) of Gaseous fuel in 2003 to that in 2006?
Provide a short and direct response. 0.7. What is the ratio of the Emissions(in percent) in Liquid fuel in 2003 to that in 2006?
Ensure brevity in your answer.  1.09. What is the ratio of the Emissions(in percent) in Solid fuel in 2003 to that in 2006?
Offer a very short reply. 0.97. What is the ratio of the Emissions(in percent) of Gaseous fuel in 2003 to that in 2007?
Keep it short and to the point. 0.69. What is the ratio of the Emissions(in percent) in Liquid fuel in 2003 to that in 2007?
Offer a very short reply. 1.1. What is the ratio of the Emissions(in percent) in Solid fuel in 2003 to that in 2007?
Keep it short and to the point. 1.13. What is the ratio of the Emissions(in percent) of Gaseous fuel in 2004 to that in 2005?
Give a very brief answer. 0.91. What is the ratio of the Emissions(in percent) in Liquid fuel in 2004 to that in 2005?
Ensure brevity in your answer.  1. What is the ratio of the Emissions(in percent) in Solid fuel in 2004 to that in 2005?
Provide a short and direct response. 1.04. What is the ratio of the Emissions(in percent) in Gaseous fuel in 2004 to that in 2006?
Keep it short and to the point. 0.85. What is the ratio of the Emissions(in percent) of Liquid fuel in 2004 to that in 2006?
Offer a very short reply. 1.05. What is the ratio of the Emissions(in percent) of Solid fuel in 2004 to that in 2006?
Provide a short and direct response. 0.97. What is the ratio of the Emissions(in percent) in Gaseous fuel in 2004 to that in 2007?
Ensure brevity in your answer.  0.84. What is the ratio of the Emissions(in percent) in Liquid fuel in 2004 to that in 2007?
Your response must be concise. 1.06. What is the ratio of the Emissions(in percent) in Solid fuel in 2004 to that in 2007?
Give a very brief answer. 1.13. What is the ratio of the Emissions(in percent) of Gaseous fuel in 2005 to that in 2006?
Offer a terse response. 0.93. What is the ratio of the Emissions(in percent) in Liquid fuel in 2005 to that in 2006?
Your answer should be very brief. 1.05. What is the ratio of the Emissions(in percent) in Solid fuel in 2005 to that in 2006?
Provide a short and direct response. 0.93. What is the ratio of the Emissions(in percent) in Gaseous fuel in 2005 to that in 2007?
Your answer should be compact. 0.92. What is the ratio of the Emissions(in percent) of Liquid fuel in 2005 to that in 2007?
Make the answer very short. 1.06. What is the ratio of the Emissions(in percent) of Solid fuel in 2005 to that in 2007?
Provide a succinct answer. 1.09. What is the ratio of the Emissions(in percent) in Gaseous fuel in 2006 to that in 2007?
Give a very brief answer. 0.98. What is the ratio of the Emissions(in percent) of Liquid fuel in 2006 to that in 2007?
Your answer should be very brief. 1.01. What is the ratio of the Emissions(in percent) of Solid fuel in 2006 to that in 2007?
Offer a very short reply. 1.17. What is the difference between the highest and the second highest Emissions(in percent) in Gaseous fuel?
Your response must be concise. 0.23. What is the difference between the highest and the second highest Emissions(in percent) in Liquid fuel?
Provide a short and direct response. 0.7. What is the difference between the highest and the second highest Emissions(in percent) in Solid fuel?
Your answer should be compact. 0.57. What is the difference between the highest and the lowest Emissions(in percent) in Gaseous fuel?
Offer a terse response. 7.45. What is the difference between the highest and the lowest Emissions(in percent) of Liquid fuel?
Offer a very short reply. 6.99. What is the difference between the highest and the lowest Emissions(in percent) in Solid fuel?
Make the answer very short. 4.84. 